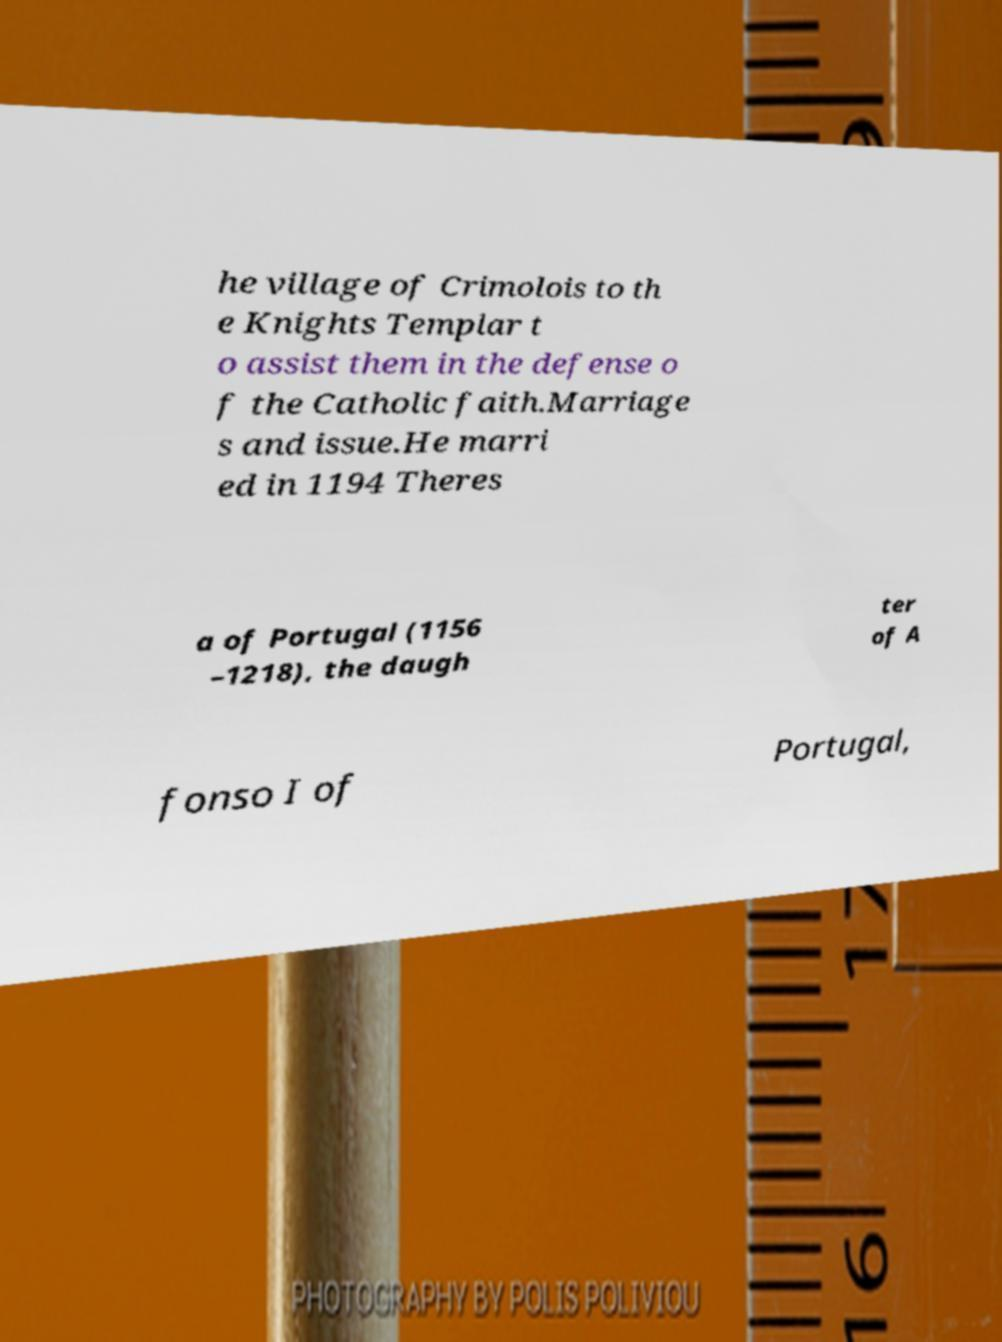I need the written content from this picture converted into text. Can you do that? he village of Crimolois to th e Knights Templar t o assist them in the defense o f the Catholic faith.Marriage s and issue.He marri ed in 1194 Theres a of Portugal (1156 –1218), the daugh ter of A fonso I of Portugal, 